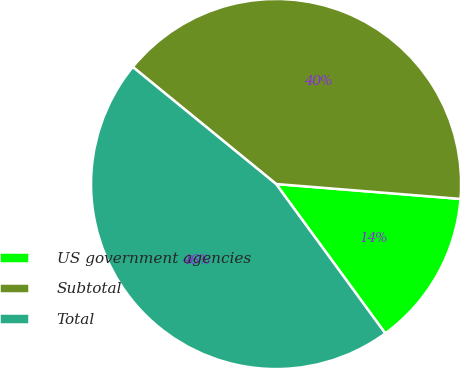Convert chart to OTSL. <chart><loc_0><loc_0><loc_500><loc_500><pie_chart><fcel>US government agencies<fcel>Subtotal<fcel>Total<nl><fcel>13.67%<fcel>40.38%<fcel>45.94%<nl></chart> 